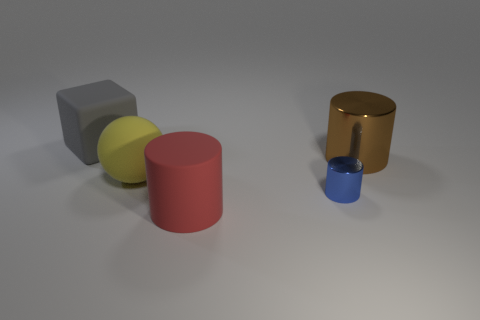Add 3 small brown shiny balls. How many objects exist? 8 Subtract all cylinders. How many objects are left? 2 Add 4 big brown metal things. How many big brown metal things exist? 5 Subtract 0 brown cubes. How many objects are left? 5 Subtract all brown cylinders. Subtract all big gray matte blocks. How many objects are left? 3 Add 3 gray matte blocks. How many gray matte blocks are left? 4 